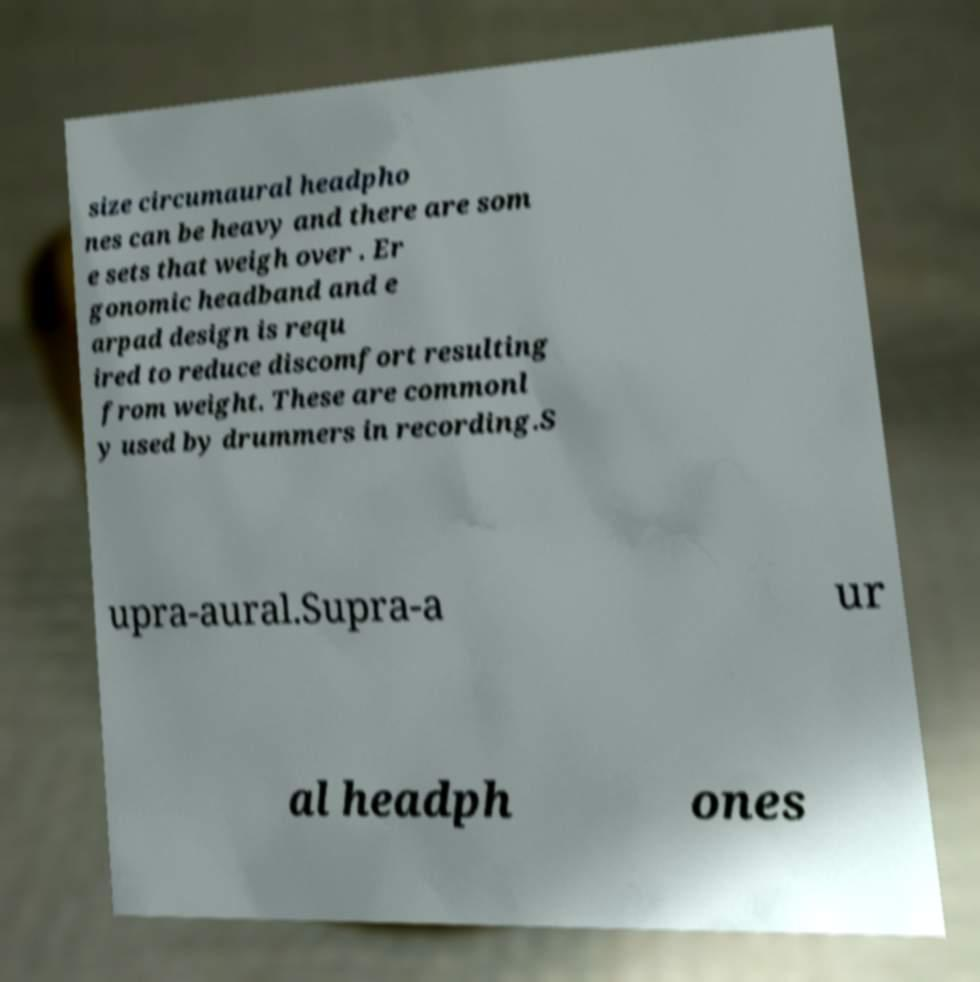Please identify and transcribe the text found in this image. size circumaural headpho nes can be heavy and there are som e sets that weigh over . Er gonomic headband and e arpad design is requ ired to reduce discomfort resulting from weight. These are commonl y used by drummers in recording.S upra-aural.Supra-a ur al headph ones 